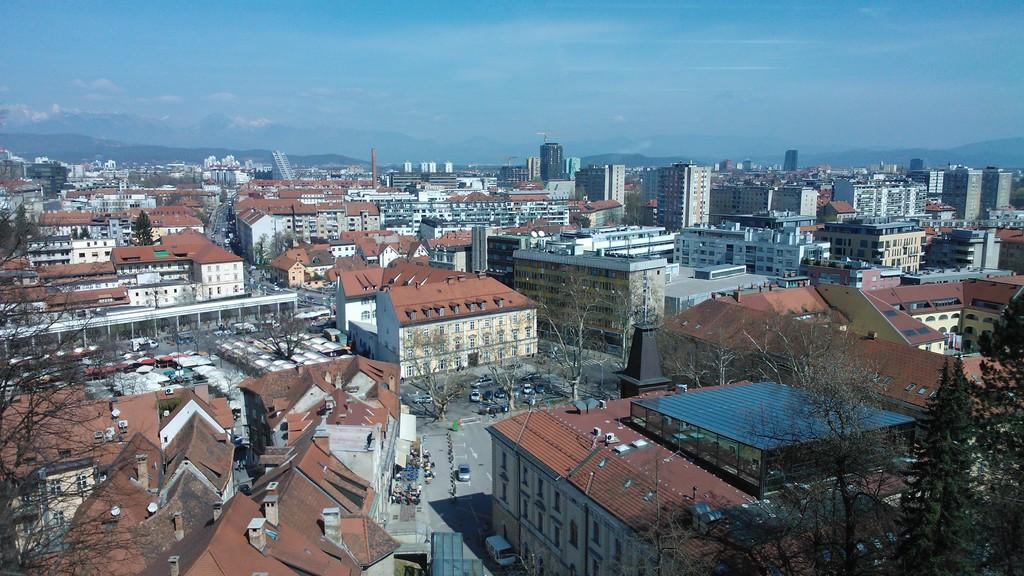What type of structures can be seen in the image? There are buildings in the image. What other natural elements are present in the image? There are trees in the image. What mode of transportation can be seen on the road in the image? There are vehicles on the road in the image. What can be seen in the background of the image? The sky is visible in the background of the image. Can you tell me how many volleyballs are visible in the image? There are no volleyballs present in the image. What type of camera is being used to take the picture in the image? There is no camera visible in the image, as it is a photograph of a scene rather than a photograph of someone taking a photograph. 